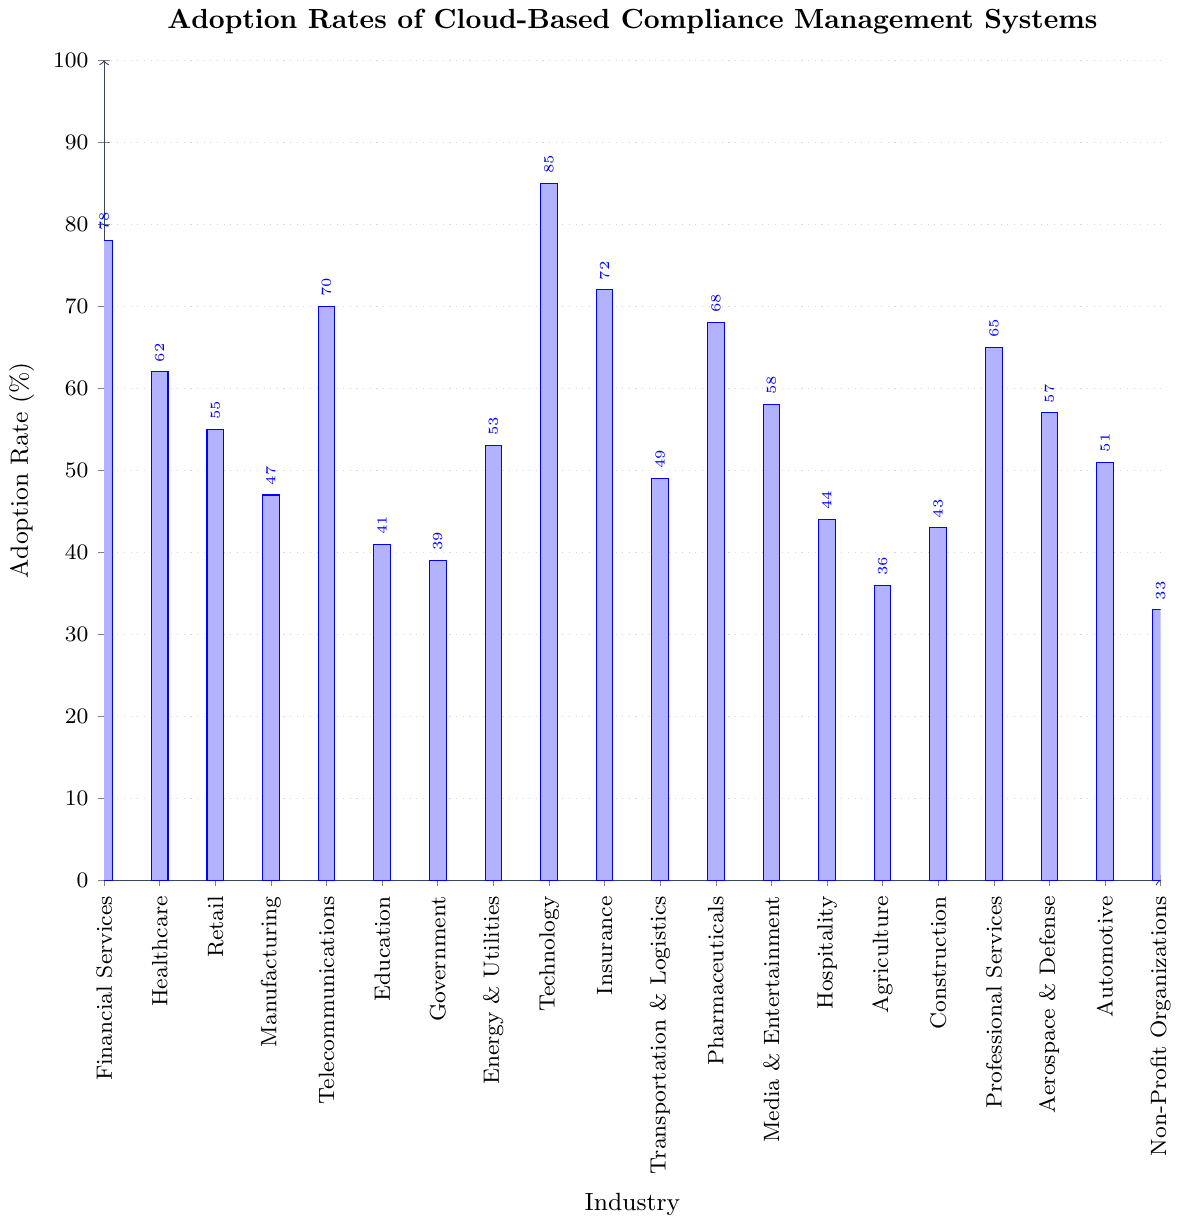Which industry has the highest adoption rate of cloud-based compliance management systems? By examining the lengths of the bars, the "Technology" industry has the tallest bar, indicating the highest adoption rate.
Answer: Technology What is the adoption rate of cloud-based compliance management systems in the Agriculture industry? Find the bar labeled "Agriculture" and read its height on the y-axis which is 36%.
Answer: 36% How does the adoption rate in Financial Services compare to that in Healthcare? The bar for Financial Services is higher than that for Healthcare. Specifically, Financial Services has an adoption rate of 78% and Healthcare has 62%.
Answer: Financial Services has a higher adoption rate What is the difference in adoption rates between the Telecommunications and Government sectors? The Telecommunications sector has an adoption rate of 70%, while Government has 39%. Subtracting these: 70% - 39% = 31%.
Answer: 31% Which two industries have the closest adoption rates? Finding the closest heights among the bars shows that Healthcare (62%) and Professional Services (65%) have close adoption rates. The difference is 3%.
Answer: Healthcare and Professional Services What is the average adoption rate for the Education, Government, and Agriculture sectors? Add the adoption rates: Education (41%) + Government (39%) + Agriculture (36%) = 116%. Then, divide by the number of industries, which is 3. 116% / 3 = 38.67%.
Answer: 38.67% Which three industries have the lowest adoption rates, and what are the rates? Look for the three shortest bars: Non-Profit Organizations (33%), Agriculture (36%), and Government (39%).
Answer: Non-Profit Organizations: 33%, Agriculture: 36%, Government: 39% Is the adoption rate of cloud-based compliance management systems higher in the Technology sector compared to the average rate across all sectors? Calculate the average rate by adding all rates and dividing by the number of industries (20). Sum = 1115%. Average = 1115% / 20 = 55.75%. Technology has 85%, which is higher.
Answer: Yes What is the combined adoption rate for the top five industries by adoption rate? Add the adoption rates for Technology (85%), Financial Services (78%), Insurance (72%), Telecommunications (70%), and Pharmaceuticals (68%): 85 + 78 + 72 + 70 + 68 = 373%.
Answer: 373% Compare the adoption rates across Financial Services, Healthcare, and Retail. Which one has the median rate? The adoption rates are 78% (Financial Services), 62% (Healthcare), and 55% (Retail). Sorting them: 55%, 62%, 78%. The median rate is 62% (Healthcare).
Answer: Healthcare 